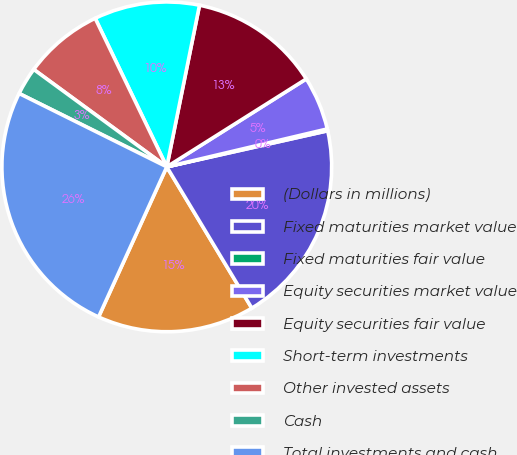Convert chart to OTSL. <chart><loc_0><loc_0><loc_500><loc_500><pie_chart><fcel>(Dollars in millions)<fcel>Fixed maturities market value<fcel>Fixed maturities fair value<fcel>Equity securities market value<fcel>Equity securities fair value<fcel>Short-term investments<fcel>Other invested assets<fcel>Cash<fcel>Total investments and cash<nl><fcel>15.41%<fcel>19.89%<fcel>0.18%<fcel>5.26%<fcel>12.87%<fcel>10.33%<fcel>7.79%<fcel>2.72%<fcel>25.55%<nl></chart> 